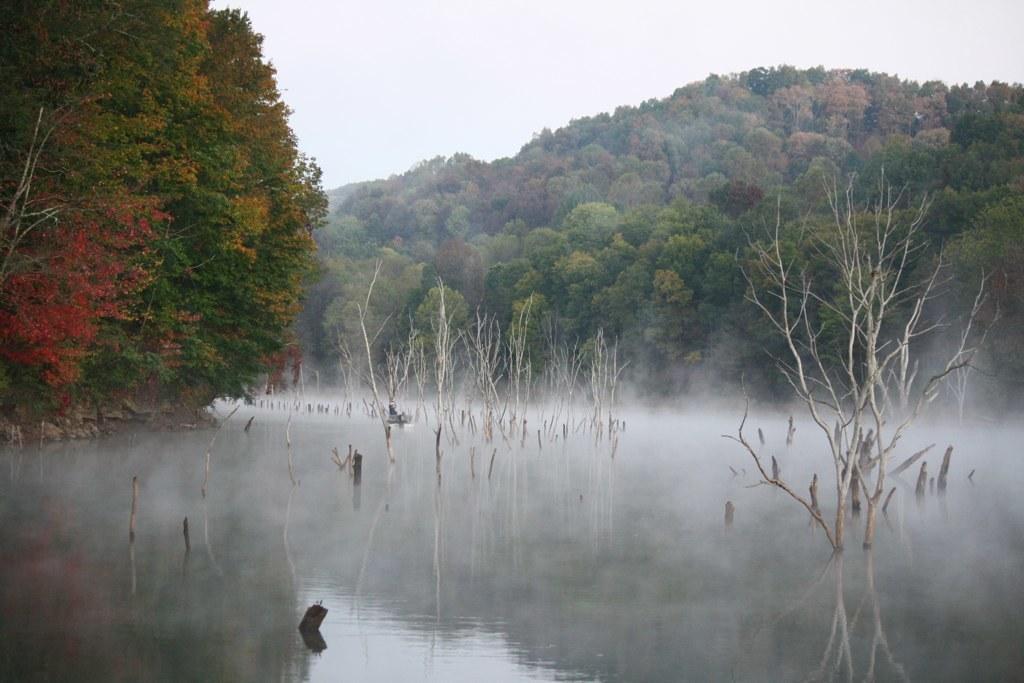Describe this image in one or two sentences. This image is taken outdoors. At the bottom of the image there is a pond with water and a few dry plants. In the background there are many trees and plants. At the top of the image there is a sky with clouds. 